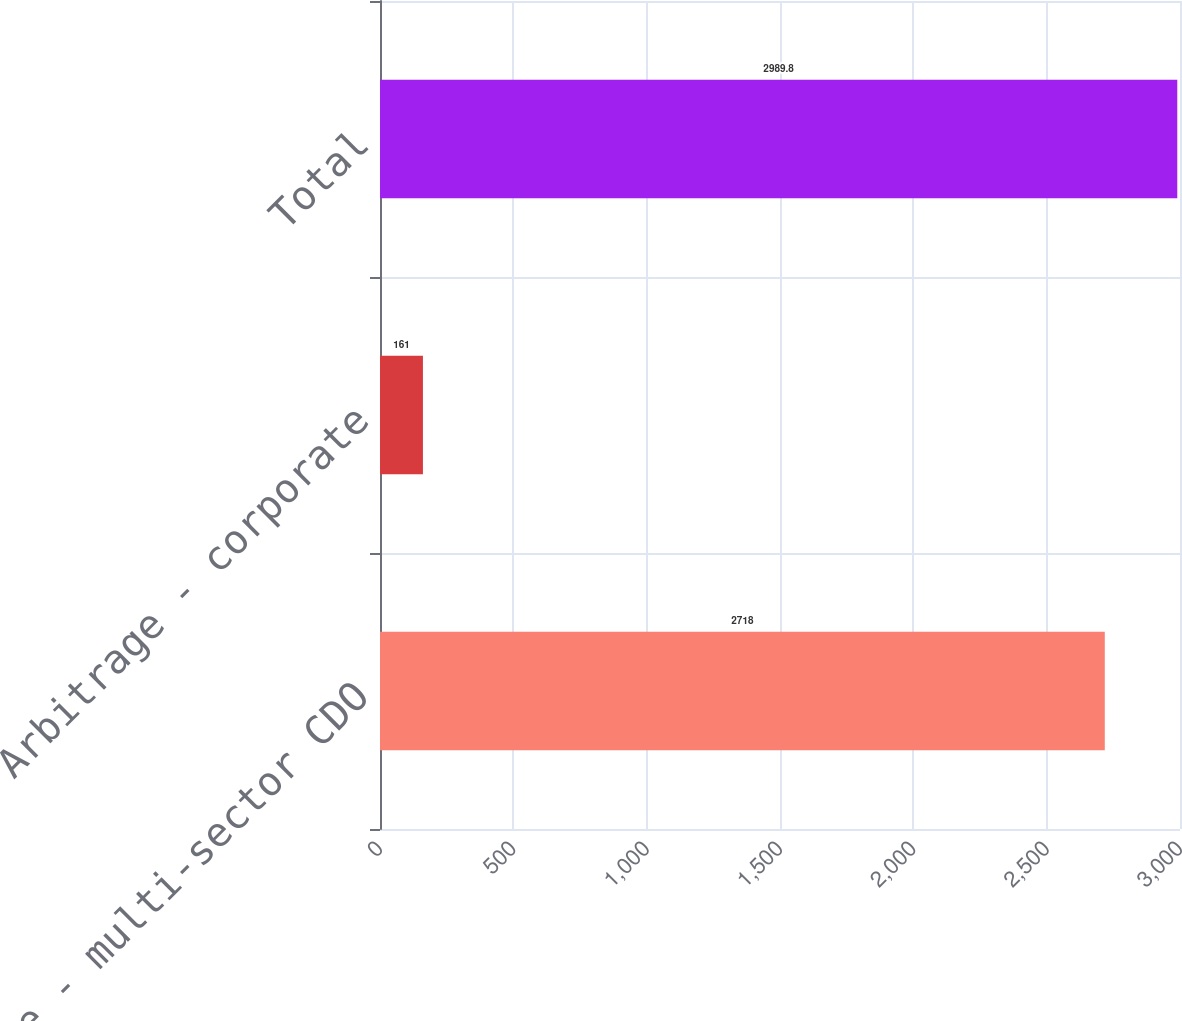<chart> <loc_0><loc_0><loc_500><loc_500><bar_chart><fcel>Arbitrage - multi-sector CDO<fcel>Arbitrage - corporate<fcel>Total<nl><fcel>2718<fcel>161<fcel>2989.8<nl></chart> 